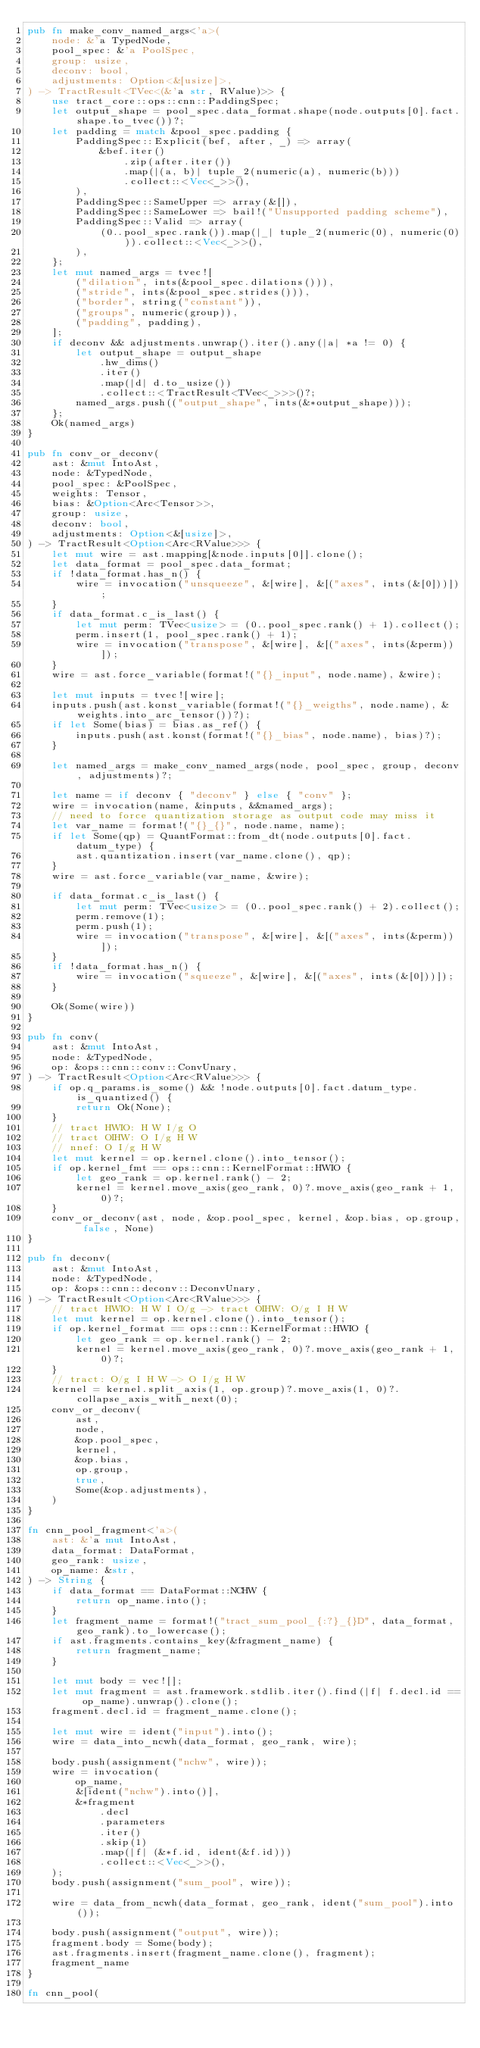Convert code to text. <code><loc_0><loc_0><loc_500><loc_500><_Rust_>pub fn make_conv_named_args<'a>(
    node: &'a TypedNode,
    pool_spec: &'a PoolSpec,
    group: usize,
    deconv: bool,
    adjustments: Option<&[usize]>,
) -> TractResult<TVec<(&'a str, RValue)>> {
    use tract_core::ops::cnn::PaddingSpec;
    let output_shape = pool_spec.data_format.shape(node.outputs[0].fact.shape.to_tvec())?;
    let padding = match &pool_spec.padding {
        PaddingSpec::Explicit(bef, after, _) => array(
            &bef.iter()
                .zip(after.iter())
                .map(|(a, b)| tuple_2(numeric(a), numeric(b)))
                .collect::<Vec<_>>(),
        ),
        PaddingSpec::SameUpper => array(&[]),
        PaddingSpec::SameLower => bail!("Unsupported padding scheme"),
        PaddingSpec::Valid => array(
            (0..pool_spec.rank()).map(|_| tuple_2(numeric(0), numeric(0))).collect::<Vec<_>>(),
        ),
    };
    let mut named_args = tvec![
        ("dilation", ints(&pool_spec.dilations())),
        ("stride", ints(&pool_spec.strides())),
        ("border", string("constant")),
        ("groups", numeric(group)),
        ("padding", padding),
    ];
    if deconv && adjustments.unwrap().iter().any(|a| *a != 0) {
        let output_shape = output_shape
            .hw_dims()
            .iter()
            .map(|d| d.to_usize())
            .collect::<TractResult<TVec<_>>>()?;
        named_args.push(("output_shape", ints(&*output_shape)));
    };
    Ok(named_args)
}

pub fn conv_or_deconv(
    ast: &mut IntoAst,
    node: &TypedNode,
    pool_spec: &PoolSpec,
    weights: Tensor,
    bias: &Option<Arc<Tensor>>,
    group: usize,
    deconv: bool,
    adjustments: Option<&[usize]>,
) -> TractResult<Option<Arc<RValue>>> {
    let mut wire = ast.mapping[&node.inputs[0]].clone();
    let data_format = pool_spec.data_format;
    if !data_format.has_n() {
        wire = invocation("unsqueeze", &[wire], &[("axes", ints(&[0]))]);
    }
    if data_format.c_is_last() {
        let mut perm: TVec<usize> = (0..pool_spec.rank() + 1).collect();
        perm.insert(1, pool_spec.rank() + 1);
        wire = invocation("transpose", &[wire], &[("axes", ints(&perm))]);
    }
    wire = ast.force_variable(format!("{}_input", node.name), &wire);

    let mut inputs = tvec![wire];
    inputs.push(ast.konst_variable(format!("{}_weigths", node.name), &weights.into_arc_tensor())?);
    if let Some(bias) = bias.as_ref() {
        inputs.push(ast.konst(format!("{}_bias", node.name), bias)?);
    }

    let named_args = make_conv_named_args(node, pool_spec, group, deconv, adjustments)?;

    let name = if deconv { "deconv" } else { "conv" };
    wire = invocation(name, &inputs, &&named_args);
    // need to force quantization storage as output code may miss it
    let var_name = format!("{}_{}", node.name, name);
    if let Some(qp) = QuantFormat::from_dt(node.outputs[0].fact.datum_type) {
        ast.quantization.insert(var_name.clone(), qp);
    }
    wire = ast.force_variable(var_name, &wire);

    if data_format.c_is_last() {
        let mut perm: TVec<usize> = (0..pool_spec.rank() + 2).collect();
        perm.remove(1);
        perm.push(1);
        wire = invocation("transpose", &[wire], &[("axes", ints(&perm))]);
    }
    if !data_format.has_n() {
        wire = invocation("squeeze", &[wire], &[("axes", ints(&[0]))]);
    }

    Ok(Some(wire))
}

pub fn conv(
    ast: &mut IntoAst,
    node: &TypedNode,
    op: &ops::cnn::conv::ConvUnary,
) -> TractResult<Option<Arc<RValue>>> {
    if op.q_params.is_some() && !node.outputs[0].fact.datum_type.is_quantized() {
        return Ok(None);
    }
    // tract HWIO: H W I/g O
    // tract OIHW: O I/g H W
    // nnef: O I/g H W
    let mut kernel = op.kernel.clone().into_tensor();
    if op.kernel_fmt == ops::cnn::KernelFormat::HWIO {
        let geo_rank = op.kernel.rank() - 2;
        kernel = kernel.move_axis(geo_rank, 0)?.move_axis(geo_rank + 1, 0)?;
    }
    conv_or_deconv(ast, node, &op.pool_spec, kernel, &op.bias, op.group, false, None)
}

pub fn deconv(
    ast: &mut IntoAst,
    node: &TypedNode,
    op: &ops::cnn::deconv::DeconvUnary,
) -> TractResult<Option<Arc<RValue>>> {
    // tract HWIO: H W I O/g -> tract OIHW: O/g I H W
    let mut kernel = op.kernel.clone().into_tensor();
    if op.kernel_format == ops::cnn::KernelFormat::HWIO {
        let geo_rank = op.kernel.rank() - 2;
        kernel = kernel.move_axis(geo_rank, 0)?.move_axis(geo_rank + 1, 0)?;
    }
    // tract: O/g I H W -> O I/g H W
    kernel = kernel.split_axis(1, op.group)?.move_axis(1, 0)?.collapse_axis_with_next(0);
    conv_or_deconv(
        ast,
        node,
        &op.pool_spec,
        kernel,
        &op.bias,
        op.group,
        true,
        Some(&op.adjustments),
    )
}

fn cnn_pool_fragment<'a>(
    ast: &'a mut IntoAst,
    data_format: DataFormat,
    geo_rank: usize,
    op_name: &str,
) -> String {
    if data_format == DataFormat::NCHW {
        return op_name.into();
    }
    let fragment_name = format!("tract_sum_pool_{:?}_{}D", data_format, geo_rank).to_lowercase();
    if ast.fragments.contains_key(&fragment_name) {
        return fragment_name;
    }

    let mut body = vec![];
    let mut fragment = ast.framework.stdlib.iter().find(|f| f.decl.id == op_name).unwrap().clone();
    fragment.decl.id = fragment_name.clone();

    let mut wire = ident("input").into();
    wire = data_into_ncwh(data_format, geo_rank, wire);

    body.push(assignment("nchw", wire));
    wire = invocation(
        op_name,
        &[ident("nchw").into()],
        &*fragment
            .decl
            .parameters
            .iter()
            .skip(1)
            .map(|f| (&*f.id, ident(&f.id)))
            .collect::<Vec<_>>(),
    );
    body.push(assignment("sum_pool", wire));

    wire = data_from_ncwh(data_format, geo_rank, ident("sum_pool").into());

    body.push(assignment("output", wire));
    fragment.body = Some(body);
    ast.fragments.insert(fragment_name.clone(), fragment);
    fragment_name
}

fn cnn_pool(</code> 